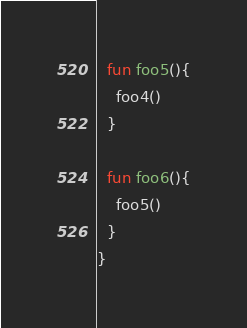Convert code to text. <code><loc_0><loc_0><loc_500><loc_500><_Kotlin_>
  fun foo5(){
    foo4()
  }

  fun foo6(){
    foo5()
  }
}</code> 